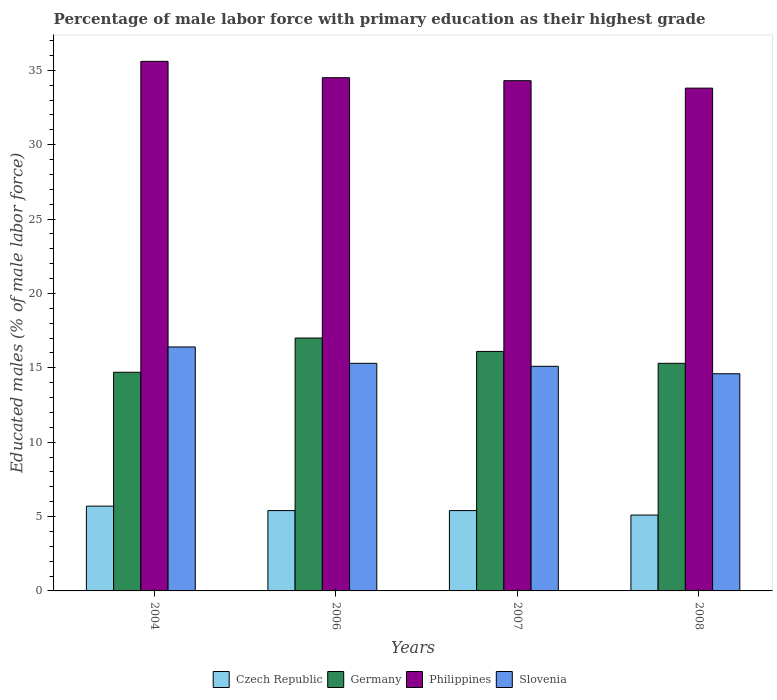How many different coloured bars are there?
Your answer should be compact. 4. Are the number of bars per tick equal to the number of legend labels?
Offer a terse response. Yes. How many bars are there on the 4th tick from the left?
Provide a succinct answer. 4. How many bars are there on the 3rd tick from the right?
Give a very brief answer. 4. What is the label of the 3rd group of bars from the left?
Provide a succinct answer. 2007. In how many cases, is the number of bars for a given year not equal to the number of legend labels?
Ensure brevity in your answer.  0. What is the percentage of male labor force with primary education in Slovenia in 2004?
Provide a short and direct response. 16.4. Across all years, what is the maximum percentage of male labor force with primary education in Czech Republic?
Offer a very short reply. 5.7. Across all years, what is the minimum percentage of male labor force with primary education in Czech Republic?
Make the answer very short. 5.1. In which year was the percentage of male labor force with primary education in Germany maximum?
Offer a terse response. 2006. What is the total percentage of male labor force with primary education in Philippines in the graph?
Keep it short and to the point. 138.2. What is the difference between the percentage of male labor force with primary education in Slovenia in 2004 and that in 2006?
Offer a very short reply. 1.1. What is the difference between the percentage of male labor force with primary education in Germany in 2008 and the percentage of male labor force with primary education in Slovenia in 2006?
Keep it short and to the point. 0. What is the average percentage of male labor force with primary education in Germany per year?
Your answer should be compact. 15.78. In the year 2007, what is the difference between the percentage of male labor force with primary education in Philippines and percentage of male labor force with primary education in Czech Republic?
Offer a very short reply. 28.9. In how many years, is the percentage of male labor force with primary education in Philippines greater than 27 %?
Give a very brief answer. 4. What is the ratio of the percentage of male labor force with primary education in Philippines in 2004 to that in 2008?
Your answer should be compact. 1.05. Is the difference between the percentage of male labor force with primary education in Philippines in 2004 and 2007 greater than the difference between the percentage of male labor force with primary education in Czech Republic in 2004 and 2007?
Keep it short and to the point. Yes. What is the difference between the highest and the second highest percentage of male labor force with primary education in Slovenia?
Your answer should be very brief. 1.1. What is the difference between the highest and the lowest percentage of male labor force with primary education in Czech Republic?
Your answer should be compact. 0.6. Is the sum of the percentage of male labor force with primary education in Slovenia in 2004 and 2006 greater than the maximum percentage of male labor force with primary education in Germany across all years?
Give a very brief answer. Yes. Is it the case that in every year, the sum of the percentage of male labor force with primary education in Slovenia and percentage of male labor force with primary education in Germany is greater than the sum of percentage of male labor force with primary education in Philippines and percentage of male labor force with primary education in Czech Republic?
Ensure brevity in your answer.  Yes. What does the 4th bar from the right in 2004 represents?
Keep it short and to the point. Czech Republic. How many bars are there?
Give a very brief answer. 16. Are all the bars in the graph horizontal?
Give a very brief answer. No. How many years are there in the graph?
Your answer should be compact. 4. What is the difference between two consecutive major ticks on the Y-axis?
Keep it short and to the point. 5. Are the values on the major ticks of Y-axis written in scientific E-notation?
Offer a terse response. No. How many legend labels are there?
Make the answer very short. 4. What is the title of the graph?
Offer a terse response. Percentage of male labor force with primary education as their highest grade. What is the label or title of the X-axis?
Make the answer very short. Years. What is the label or title of the Y-axis?
Offer a very short reply. Educated males (% of male labor force). What is the Educated males (% of male labor force) of Czech Republic in 2004?
Give a very brief answer. 5.7. What is the Educated males (% of male labor force) in Germany in 2004?
Provide a succinct answer. 14.7. What is the Educated males (% of male labor force) of Philippines in 2004?
Provide a short and direct response. 35.6. What is the Educated males (% of male labor force) of Slovenia in 2004?
Provide a short and direct response. 16.4. What is the Educated males (% of male labor force) of Czech Republic in 2006?
Provide a succinct answer. 5.4. What is the Educated males (% of male labor force) of Philippines in 2006?
Your response must be concise. 34.5. What is the Educated males (% of male labor force) in Slovenia in 2006?
Ensure brevity in your answer.  15.3. What is the Educated males (% of male labor force) in Czech Republic in 2007?
Ensure brevity in your answer.  5.4. What is the Educated males (% of male labor force) in Germany in 2007?
Ensure brevity in your answer.  16.1. What is the Educated males (% of male labor force) of Philippines in 2007?
Provide a succinct answer. 34.3. What is the Educated males (% of male labor force) in Slovenia in 2007?
Provide a short and direct response. 15.1. What is the Educated males (% of male labor force) of Czech Republic in 2008?
Offer a terse response. 5.1. What is the Educated males (% of male labor force) of Germany in 2008?
Your answer should be very brief. 15.3. What is the Educated males (% of male labor force) of Philippines in 2008?
Provide a short and direct response. 33.8. What is the Educated males (% of male labor force) in Slovenia in 2008?
Offer a terse response. 14.6. Across all years, what is the maximum Educated males (% of male labor force) in Czech Republic?
Offer a terse response. 5.7. Across all years, what is the maximum Educated males (% of male labor force) of Germany?
Your response must be concise. 17. Across all years, what is the maximum Educated males (% of male labor force) of Philippines?
Keep it short and to the point. 35.6. Across all years, what is the maximum Educated males (% of male labor force) in Slovenia?
Give a very brief answer. 16.4. Across all years, what is the minimum Educated males (% of male labor force) of Czech Republic?
Your answer should be compact. 5.1. Across all years, what is the minimum Educated males (% of male labor force) in Germany?
Make the answer very short. 14.7. Across all years, what is the minimum Educated males (% of male labor force) in Philippines?
Provide a succinct answer. 33.8. Across all years, what is the minimum Educated males (% of male labor force) of Slovenia?
Make the answer very short. 14.6. What is the total Educated males (% of male labor force) of Czech Republic in the graph?
Your answer should be very brief. 21.6. What is the total Educated males (% of male labor force) in Germany in the graph?
Make the answer very short. 63.1. What is the total Educated males (% of male labor force) of Philippines in the graph?
Make the answer very short. 138.2. What is the total Educated males (% of male labor force) of Slovenia in the graph?
Your response must be concise. 61.4. What is the difference between the Educated males (% of male labor force) of Czech Republic in 2004 and that in 2006?
Ensure brevity in your answer.  0.3. What is the difference between the Educated males (% of male labor force) of Philippines in 2004 and that in 2006?
Give a very brief answer. 1.1. What is the difference between the Educated males (% of male labor force) of Slovenia in 2004 and that in 2006?
Give a very brief answer. 1.1. What is the difference between the Educated males (% of male labor force) in Czech Republic in 2004 and that in 2007?
Your answer should be compact. 0.3. What is the difference between the Educated males (% of male labor force) in Germany in 2004 and that in 2007?
Keep it short and to the point. -1.4. What is the difference between the Educated males (% of male labor force) of Philippines in 2004 and that in 2007?
Provide a succinct answer. 1.3. What is the difference between the Educated males (% of male labor force) of Slovenia in 2004 and that in 2007?
Provide a succinct answer. 1.3. What is the difference between the Educated males (% of male labor force) of Slovenia in 2006 and that in 2007?
Give a very brief answer. 0.2. What is the difference between the Educated males (% of male labor force) of Czech Republic in 2006 and that in 2008?
Provide a succinct answer. 0.3. What is the difference between the Educated males (% of male labor force) in Slovenia in 2006 and that in 2008?
Offer a very short reply. 0.7. What is the difference between the Educated males (% of male labor force) in Czech Republic in 2004 and the Educated males (% of male labor force) in Germany in 2006?
Your answer should be compact. -11.3. What is the difference between the Educated males (% of male labor force) of Czech Republic in 2004 and the Educated males (% of male labor force) of Philippines in 2006?
Your answer should be compact. -28.8. What is the difference between the Educated males (% of male labor force) of Germany in 2004 and the Educated males (% of male labor force) of Philippines in 2006?
Your answer should be compact. -19.8. What is the difference between the Educated males (% of male labor force) of Philippines in 2004 and the Educated males (% of male labor force) of Slovenia in 2006?
Your answer should be compact. 20.3. What is the difference between the Educated males (% of male labor force) in Czech Republic in 2004 and the Educated males (% of male labor force) in Germany in 2007?
Provide a succinct answer. -10.4. What is the difference between the Educated males (% of male labor force) in Czech Republic in 2004 and the Educated males (% of male labor force) in Philippines in 2007?
Your response must be concise. -28.6. What is the difference between the Educated males (% of male labor force) in Germany in 2004 and the Educated males (% of male labor force) in Philippines in 2007?
Your answer should be very brief. -19.6. What is the difference between the Educated males (% of male labor force) in Germany in 2004 and the Educated males (% of male labor force) in Slovenia in 2007?
Your answer should be compact. -0.4. What is the difference between the Educated males (% of male labor force) in Philippines in 2004 and the Educated males (% of male labor force) in Slovenia in 2007?
Provide a short and direct response. 20.5. What is the difference between the Educated males (% of male labor force) in Czech Republic in 2004 and the Educated males (% of male labor force) in Germany in 2008?
Offer a terse response. -9.6. What is the difference between the Educated males (% of male labor force) in Czech Republic in 2004 and the Educated males (% of male labor force) in Philippines in 2008?
Your response must be concise. -28.1. What is the difference between the Educated males (% of male labor force) in Germany in 2004 and the Educated males (% of male labor force) in Philippines in 2008?
Your answer should be very brief. -19.1. What is the difference between the Educated males (% of male labor force) in Philippines in 2004 and the Educated males (% of male labor force) in Slovenia in 2008?
Keep it short and to the point. 21. What is the difference between the Educated males (% of male labor force) in Czech Republic in 2006 and the Educated males (% of male labor force) in Philippines in 2007?
Provide a short and direct response. -28.9. What is the difference between the Educated males (% of male labor force) of Czech Republic in 2006 and the Educated males (% of male labor force) of Slovenia in 2007?
Make the answer very short. -9.7. What is the difference between the Educated males (% of male labor force) in Germany in 2006 and the Educated males (% of male labor force) in Philippines in 2007?
Ensure brevity in your answer.  -17.3. What is the difference between the Educated males (% of male labor force) of Germany in 2006 and the Educated males (% of male labor force) of Slovenia in 2007?
Give a very brief answer. 1.9. What is the difference between the Educated males (% of male labor force) of Philippines in 2006 and the Educated males (% of male labor force) of Slovenia in 2007?
Your response must be concise. 19.4. What is the difference between the Educated males (% of male labor force) in Czech Republic in 2006 and the Educated males (% of male labor force) in Germany in 2008?
Provide a short and direct response. -9.9. What is the difference between the Educated males (% of male labor force) in Czech Republic in 2006 and the Educated males (% of male labor force) in Philippines in 2008?
Provide a succinct answer. -28.4. What is the difference between the Educated males (% of male labor force) of Czech Republic in 2006 and the Educated males (% of male labor force) of Slovenia in 2008?
Your answer should be very brief. -9.2. What is the difference between the Educated males (% of male labor force) in Germany in 2006 and the Educated males (% of male labor force) in Philippines in 2008?
Your response must be concise. -16.8. What is the difference between the Educated males (% of male labor force) of Germany in 2006 and the Educated males (% of male labor force) of Slovenia in 2008?
Your answer should be very brief. 2.4. What is the difference between the Educated males (% of male labor force) in Philippines in 2006 and the Educated males (% of male labor force) in Slovenia in 2008?
Give a very brief answer. 19.9. What is the difference between the Educated males (% of male labor force) in Czech Republic in 2007 and the Educated males (% of male labor force) in Germany in 2008?
Keep it short and to the point. -9.9. What is the difference between the Educated males (% of male labor force) in Czech Republic in 2007 and the Educated males (% of male labor force) in Philippines in 2008?
Make the answer very short. -28.4. What is the difference between the Educated males (% of male labor force) in Germany in 2007 and the Educated males (% of male labor force) in Philippines in 2008?
Your answer should be compact. -17.7. What is the average Educated males (% of male labor force) in Czech Republic per year?
Give a very brief answer. 5.4. What is the average Educated males (% of male labor force) in Germany per year?
Give a very brief answer. 15.78. What is the average Educated males (% of male labor force) in Philippines per year?
Keep it short and to the point. 34.55. What is the average Educated males (% of male labor force) of Slovenia per year?
Provide a short and direct response. 15.35. In the year 2004, what is the difference between the Educated males (% of male labor force) of Czech Republic and Educated males (% of male labor force) of Philippines?
Give a very brief answer. -29.9. In the year 2004, what is the difference between the Educated males (% of male labor force) of Czech Republic and Educated males (% of male labor force) of Slovenia?
Provide a succinct answer. -10.7. In the year 2004, what is the difference between the Educated males (% of male labor force) in Germany and Educated males (% of male labor force) in Philippines?
Keep it short and to the point. -20.9. In the year 2006, what is the difference between the Educated males (% of male labor force) in Czech Republic and Educated males (% of male labor force) in Germany?
Your answer should be compact. -11.6. In the year 2006, what is the difference between the Educated males (% of male labor force) of Czech Republic and Educated males (% of male labor force) of Philippines?
Provide a succinct answer. -29.1. In the year 2006, what is the difference between the Educated males (% of male labor force) in Germany and Educated males (% of male labor force) in Philippines?
Provide a succinct answer. -17.5. In the year 2006, what is the difference between the Educated males (% of male labor force) of Germany and Educated males (% of male labor force) of Slovenia?
Your response must be concise. 1.7. In the year 2007, what is the difference between the Educated males (% of male labor force) of Czech Republic and Educated males (% of male labor force) of Germany?
Your response must be concise. -10.7. In the year 2007, what is the difference between the Educated males (% of male labor force) in Czech Republic and Educated males (% of male labor force) in Philippines?
Your answer should be compact. -28.9. In the year 2007, what is the difference between the Educated males (% of male labor force) in Germany and Educated males (% of male labor force) in Philippines?
Your response must be concise. -18.2. In the year 2007, what is the difference between the Educated males (% of male labor force) of Germany and Educated males (% of male labor force) of Slovenia?
Keep it short and to the point. 1. In the year 2008, what is the difference between the Educated males (% of male labor force) of Czech Republic and Educated males (% of male labor force) of Germany?
Ensure brevity in your answer.  -10.2. In the year 2008, what is the difference between the Educated males (% of male labor force) in Czech Republic and Educated males (% of male labor force) in Philippines?
Ensure brevity in your answer.  -28.7. In the year 2008, what is the difference between the Educated males (% of male labor force) of Czech Republic and Educated males (% of male labor force) of Slovenia?
Provide a short and direct response. -9.5. In the year 2008, what is the difference between the Educated males (% of male labor force) of Germany and Educated males (% of male labor force) of Philippines?
Keep it short and to the point. -18.5. In the year 2008, what is the difference between the Educated males (% of male labor force) of Germany and Educated males (% of male labor force) of Slovenia?
Your answer should be very brief. 0.7. In the year 2008, what is the difference between the Educated males (% of male labor force) in Philippines and Educated males (% of male labor force) in Slovenia?
Your response must be concise. 19.2. What is the ratio of the Educated males (% of male labor force) of Czech Republic in 2004 to that in 2006?
Make the answer very short. 1.06. What is the ratio of the Educated males (% of male labor force) of Germany in 2004 to that in 2006?
Make the answer very short. 0.86. What is the ratio of the Educated males (% of male labor force) of Philippines in 2004 to that in 2006?
Your answer should be very brief. 1.03. What is the ratio of the Educated males (% of male labor force) of Slovenia in 2004 to that in 2006?
Ensure brevity in your answer.  1.07. What is the ratio of the Educated males (% of male labor force) of Czech Republic in 2004 to that in 2007?
Your answer should be compact. 1.06. What is the ratio of the Educated males (% of male labor force) in Philippines in 2004 to that in 2007?
Offer a very short reply. 1.04. What is the ratio of the Educated males (% of male labor force) in Slovenia in 2004 to that in 2007?
Provide a short and direct response. 1.09. What is the ratio of the Educated males (% of male labor force) of Czech Republic in 2004 to that in 2008?
Your answer should be very brief. 1.12. What is the ratio of the Educated males (% of male labor force) of Germany in 2004 to that in 2008?
Offer a terse response. 0.96. What is the ratio of the Educated males (% of male labor force) of Philippines in 2004 to that in 2008?
Your answer should be very brief. 1.05. What is the ratio of the Educated males (% of male labor force) in Slovenia in 2004 to that in 2008?
Offer a terse response. 1.12. What is the ratio of the Educated males (% of male labor force) in Germany in 2006 to that in 2007?
Your answer should be compact. 1.06. What is the ratio of the Educated males (% of male labor force) of Slovenia in 2006 to that in 2007?
Give a very brief answer. 1.01. What is the ratio of the Educated males (% of male labor force) of Czech Republic in 2006 to that in 2008?
Give a very brief answer. 1.06. What is the ratio of the Educated males (% of male labor force) in Philippines in 2006 to that in 2008?
Your response must be concise. 1.02. What is the ratio of the Educated males (% of male labor force) in Slovenia in 2006 to that in 2008?
Keep it short and to the point. 1.05. What is the ratio of the Educated males (% of male labor force) in Czech Republic in 2007 to that in 2008?
Make the answer very short. 1.06. What is the ratio of the Educated males (% of male labor force) of Germany in 2007 to that in 2008?
Give a very brief answer. 1.05. What is the ratio of the Educated males (% of male labor force) of Philippines in 2007 to that in 2008?
Your response must be concise. 1.01. What is the ratio of the Educated males (% of male labor force) in Slovenia in 2007 to that in 2008?
Keep it short and to the point. 1.03. What is the difference between the highest and the second highest Educated males (% of male labor force) of Philippines?
Provide a succinct answer. 1.1. What is the difference between the highest and the lowest Educated males (% of male labor force) in Czech Republic?
Provide a succinct answer. 0.6. What is the difference between the highest and the lowest Educated males (% of male labor force) in Philippines?
Make the answer very short. 1.8. 